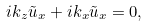Convert formula to latex. <formula><loc_0><loc_0><loc_500><loc_500>i k _ { z } \tilde { u } _ { x } + i k _ { x } \tilde { u } _ { x } = 0 ,</formula> 